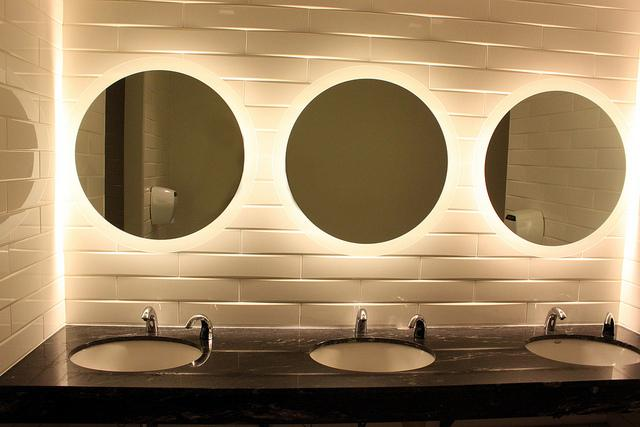How many sinks are on the row at this public bathroom area?

Choices:
A) one
B) four
C) two
D) three three 